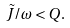<formula> <loc_0><loc_0><loc_500><loc_500>\tilde { J } / \omega < Q .</formula> 